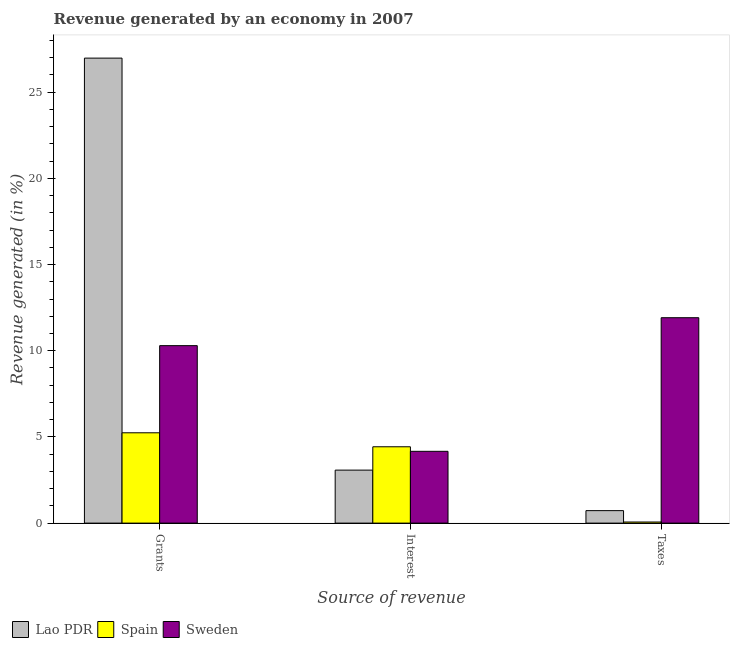How many groups of bars are there?
Keep it short and to the point. 3. Are the number of bars per tick equal to the number of legend labels?
Offer a terse response. Yes. How many bars are there on the 3rd tick from the left?
Your answer should be compact. 3. How many bars are there on the 2nd tick from the right?
Give a very brief answer. 3. What is the label of the 1st group of bars from the left?
Your response must be concise. Grants. What is the percentage of revenue generated by interest in Lao PDR?
Your answer should be very brief. 3.07. Across all countries, what is the maximum percentage of revenue generated by taxes?
Provide a short and direct response. 11.91. Across all countries, what is the minimum percentage of revenue generated by interest?
Offer a terse response. 3.07. In which country was the percentage of revenue generated by taxes maximum?
Ensure brevity in your answer.  Sweden. In which country was the percentage of revenue generated by grants minimum?
Offer a terse response. Spain. What is the total percentage of revenue generated by taxes in the graph?
Give a very brief answer. 12.7. What is the difference between the percentage of revenue generated by taxes in Sweden and that in Lao PDR?
Offer a terse response. 11.19. What is the difference between the percentage of revenue generated by grants in Lao PDR and the percentage of revenue generated by interest in Spain?
Your response must be concise. 22.54. What is the average percentage of revenue generated by taxes per country?
Give a very brief answer. 4.23. What is the difference between the percentage of revenue generated by taxes and percentage of revenue generated by interest in Lao PDR?
Ensure brevity in your answer.  -2.35. In how many countries, is the percentage of revenue generated by taxes greater than 12 %?
Provide a succinct answer. 0. What is the ratio of the percentage of revenue generated by interest in Spain to that in Sweden?
Your answer should be very brief. 1.06. What is the difference between the highest and the second highest percentage of revenue generated by interest?
Your answer should be very brief. 0.26. What is the difference between the highest and the lowest percentage of revenue generated by taxes?
Your answer should be very brief. 11.85. In how many countries, is the percentage of revenue generated by grants greater than the average percentage of revenue generated by grants taken over all countries?
Offer a terse response. 1. What does the 1st bar from the left in Grants represents?
Make the answer very short. Lao PDR. What does the 1st bar from the right in Taxes represents?
Your answer should be very brief. Sweden. How many countries are there in the graph?
Provide a succinct answer. 3. What is the difference between two consecutive major ticks on the Y-axis?
Make the answer very short. 5. Does the graph contain any zero values?
Your answer should be compact. No. Where does the legend appear in the graph?
Ensure brevity in your answer.  Bottom left. How are the legend labels stacked?
Your answer should be very brief. Horizontal. What is the title of the graph?
Provide a succinct answer. Revenue generated by an economy in 2007. Does "Hong Kong" appear as one of the legend labels in the graph?
Provide a succinct answer. No. What is the label or title of the X-axis?
Your answer should be compact. Source of revenue. What is the label or title of the Y-axis?
Provide a succinct answer. Revenue generated (in %). What is the Revenue generated (in %) of Lao PDR in Grants?
Make the answer very short. 26.97. What is the Revenue generated (in %) in Spain in Grants?
Offer a terse response. 5.24. What is the Revenue generated (in %) of Sweden in Grants?
Ensure brevity in your answer.  10.29. What is the Revenue generated (in %) of Lao PDR in Interest?
Your answer should be compact. 3.07. What is the Revenue generated (in %) in Spain in Interest?
Offer a very short reply. 4.43. What is the Revenue generated (in %) of Sweden in Interest?
Provide a short and direct response. 4.16. What is the Revenue generated (in %) in Lao PDR in Taxes?
Offer a very short reply. 0.72. What is the Revenue generated (in %) of Spain in Taxes?
Offer a very short reply. 0.06. What is the Revenue generated (in %) of Sweden in Taxes?
Keep it short and to the point. 11.91. Across all Source of revenue, what is the maximum Revenue generated (in %) of Lao PDR?
Keep it short and to the point. 26.97. Across all Source of revenue, what is the maximum Revenue generated (in %) in Spain?
Offer a terse response. 5.24. Across all Source of revenue, what is the maximum Revenue generated (in %) of Sweden?
Provide a succinct answer. 11.91. Across all Source of revenue, what is the minimum Revenue generated (in %) of Lao PDR?
Give a very brief answer. 0.72. Across all Source of revenue, what is the minimum Revenue generated (in %) in Spain?
Provide a short and direct response. 0.06. Across all Source of revenue, what is the minimum Revenue generated (in %) of Sweden?
Your response must be concise. 4.16. What is the total Revenue generated (in %) in Lao PDR in the graph?
Your answer should be very brief. 30.77. What is the total Revenue generated (in %) of Spain in the graph?
Your answer should be compact. 9.73. What is the total Revenue generated (in %) of Sweden in the graph?
Keep it short and to the point. 26.37. What is the difference between the Revenue generated (in %) of Lao PDR in Grants and that in Interest?
Offer a terse response. 23.9. What is the difference between the Revenue generated (in %) of Spain in Grants and that in Interest?
Keep it short and to the point. 0.81. What is the difference between the Revenue generated (in %) in Sweden in Grants and that in Interest?
Provide a short and direct response. 6.13. What is the difference between the Revenue generated (in %) of Lao PDR in Grants and that in Taxes?
Provide a short and direct response. 26.25. What is the difference between the Revenue generated (in %) in Spain in Grants and that in Taxes?
Make the answer very short. 5.18. What is the difference between the Revenue generated (in %) in Sweden in Grants and that in Taxes?
Your response must be concise. -1.62. What is the difference between the Revenue generated (in %) of Lao PDR in Interest and that in Taxes?
Offer a very short reply. 2.35. What is the difference between the Revenue generated (in %) of Spain in Interest and that in Taxes?
Offer a very short reply. 4.36. What is the difference between the Revenue generated (in %) of Sweden in Interest and that in Taxes?
Make the answer very short. -7.75. What is the difference between the Revenue generated (in %) of Lao PDR in Grants and the Revenue generated (in %) of Spain in Interest?
Offer a terse response. 22.54. What is the difference between the Revenue generated (in %) of Lao PDR in Grants and the Revenue generated (in %) of Sweden in Interest?
Offer a very short reply. 22.81. What is the difference between the Revenue generated (in %) of Spain in Grants and the Revenue generated (in %) of Sweden in Interest?
Your response must be concise. 1.07. What is the difference between the Revenue generated (in %) of Lao PDR in Grants and the Revenue generated (in %) of Spain in Taxes?
Offer a very short reply. 26.91. What is the difference between the Revenue generated (in %) of Lao PDR in Grants and the Revenue generated (in %) of Sweden in Taxes?
Your answer should be very brief. 15.06. What is the difference between the Revenue generated (in %) in Spain in Grants and the Revenue generated (in %) in Sweden in Taxes?
Offer a terse response. -6.68. What is the difference between the Revenue generated (in %) in Lao PDR in Interest and the Revenue generated (in %) in Spain in Taxes?
Your response must be concise. 3.01. What is the difference between the Revenue generated (in %) of Lao PDR in Interest and the Revenue generated (in %) of Sweden in Taxes?
Provide a short and direct response. -8.84. What is the difference between the Revenue generated (in %) of Spain in Interest and the Revenue generated (in %) of Sweden in Taxes?
Give a very brief answer. -7.49. What is the average Revenue generated (in %) in Lao PDR per Source of revenue?
Give a very brief answer. 10.26. What is the average Revenue generated (in %) in Spain per Source of revenue?
Provide a succinct answer. 3.24. What is the average Revenue generated (in %) of Sweden per Source of revenue?
Your answer should be very brief. 8.79. What is the difference between the Revenue generated (in %) of Lao PDR and Revenue generated (in %) of Spain in Grants?
Offer a terse response. 21.73. What is the difference between the Revenue generated (in %) in Lao PDR and Revenue generated (in %) in Sweden in Grants?
Offer a terse response. 16.68. What is the difference between the Revenue generated (in %) in Spain and Revenue generated (in %) in Sweden in Grants?
Offer a terse response. -5.05. What is the difference between the Revenue generated (in %) of Lao PDR and Revenue generated (in %) of Spain in Interest?
Your answer should be compact. -1.35. What is the difference between the Revenue generated (in %) of Lao PDR and Revenue generated (in %) of Sweden in Interest?
Your answer should be very brief. -1.09. What is the difference between the Revenue generated (in %) in Spain and Revenue generated (in %) in Sweden in Interest?
Your answer should be compact. 0.26. What is the difference between the Revenue generated (in %) in Lao PDR and Revenue generated (in %) in Spain in Taxes?
Your response must be concise. 0.66. What is the difference between the Revenue generated (in %) in Lao PDR and Revenue generated (in %) in Sweden in Taxes?
Offer a very short reply. -11.19. What is the difference between the Revenue generated (in %) of Spain and Revenue generated (in %) of Sweden in Taxes?
Keep it short and to the point. -11.85. What is the ratio of the Revenue generated (in %) in Lao PDR in Grants to that in Interest?
Provide a short and direct response. 8.77. What is the ratio of the Revenue generated (in %) in Spain in Grants to that in Interest?
Make the answer very short. 1.18. What is the ratio of the Revenue generated (in %) of Sweden in Grants to that in Interest?
Offer a terse response. 2.47. What is the ratio of the Revenue generated (in %) of Lao PDR in Grants to that in Taxes?
Your answer should be very brief. 37.27. What is the ratio of the Revenue generated (in %) of Spain in Grants to that in Taxes?
Make the answer very short. 81.63. What is the ratio of the Revenue generated (in %) of Sweden in Grants to that in Taxes?
Provide a succinct answer. 0.86. What is the ratio of the Revenue generated (in %) in Lao PDR in Interest to that in Taxes?
Provide a succinct answer. 4.25. What is the ratio of the Revenue generated (in %) of Spain in Interest to that in Taxes?
Ensure brevity in your answer.  68.99. What is the ratio of the Revenue generated (in %) of Sweden in Interest to that in Taxes?
Offer a terse response. 0.35. What is the difference between the highest and the second highest Revenue generated (in %) of Lao PDR?
Ensure brevity in your answer.  23.9. What is the difference between the highest and the second highest Revenue generated (in %) in Spain?
Ensure brevity in your answer.  0.81. What is the difference between the highest and the second highest Revenue generated (in %) in Sweden?
Ensure brevity in your answer.  1.62. What is the difference between the highest and the lowest Revenue generated (in %) of Lao PDR?
Ensure brevity in your answer.  26.25. What is the difference between the highest and the lowest Revenue generated (in %) in Spain?
Your answer should be compact. 5.18. What is the difference between the highest and the lowest Revenue generated (in %) in Sweden?
Offer a terse response. 7.75. 